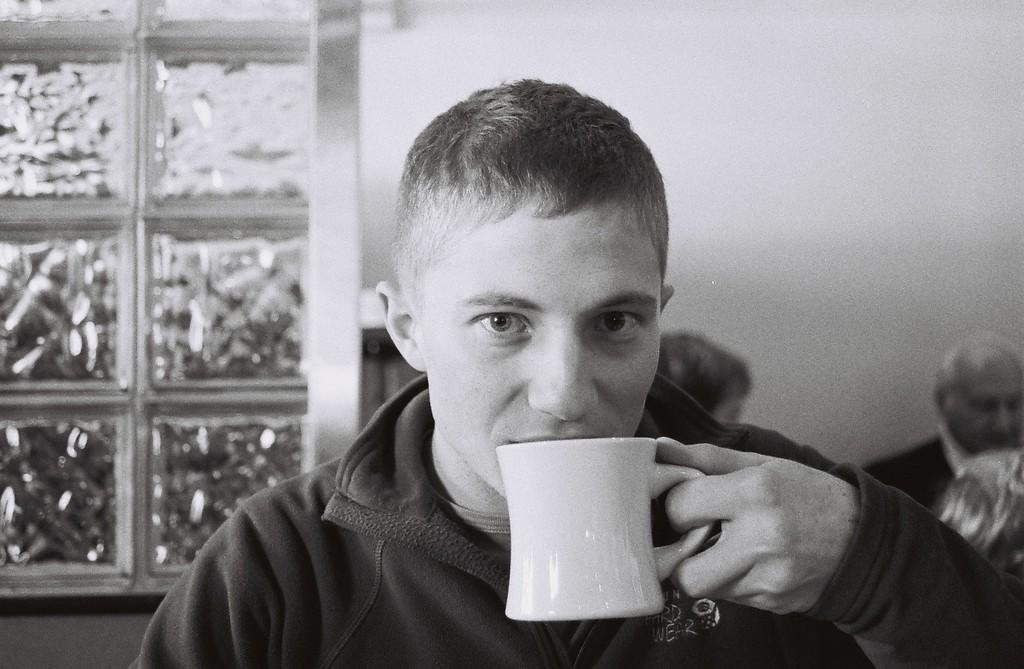Who is present in the image? There is a man in the image. What is the man doing in the image? The man is drinking a liquid in the image. How is the man holding the liquid? The man is holding a cup in his hands. What can be seen in the background of the image? There is a window in the image. What type of mint is the man using to flavor his drink in the image? There is no mint present in the image, and the man's drink is not mentioned as being flavored with mint. 